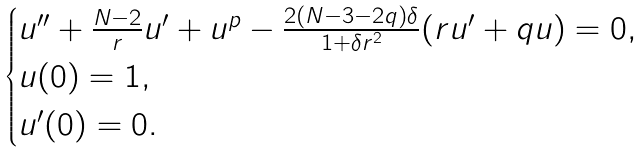<formula> <loc_0><loc_0><loc_500><loc_500>\begin{cases} u ^ { \prime \prime } + \frac { N - 2 } { r } u ^ { \prime } + u ^ { p } - \frac { 2 ( N - 3 - 2 q ) \delta } { 1 + \delta r ^ { 2 } } ( r u ^ { \prime } + q u ) = 0 , \\ u ( 0 ) = 1 , \\ u ^ { \prime } ( 0 ) = 0 . \end{cases}</formula> 